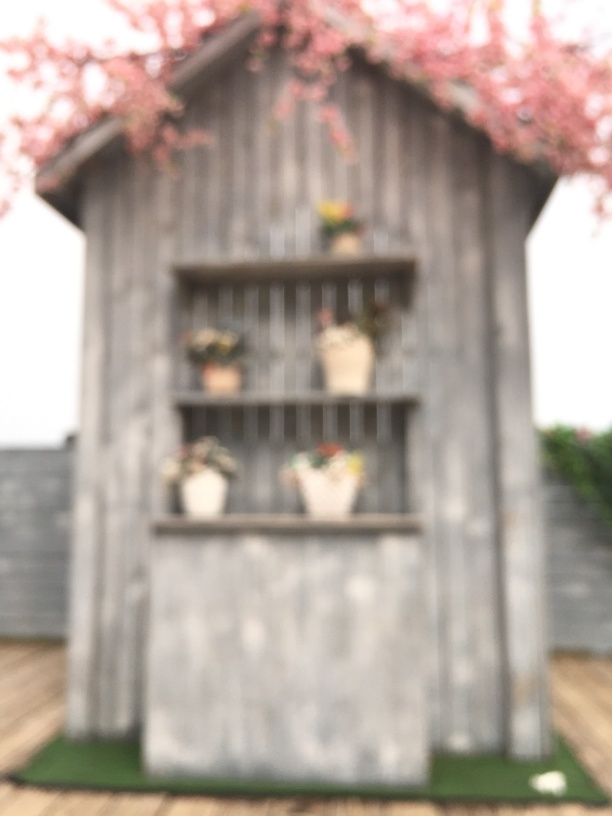What can you tell me about the structure in the image? The structure is a wooden building, possibly an outdoor shed or barn, with a rustic and timeless charm. The blurred effect suggests a dreamy or nostalgic atmosphere, and there are shelves with flower pots that contribute to its quaint and bucolic feel. 